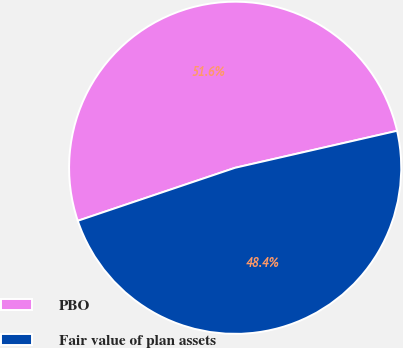Convert chart. <chart><loc_0><loc_0><loc_500><loc_500><pie_chart><fcel>PBO<fcel>Fair value of plan assets<nl><fcel>51.6%<fcel>48.4%<nl></chart> 